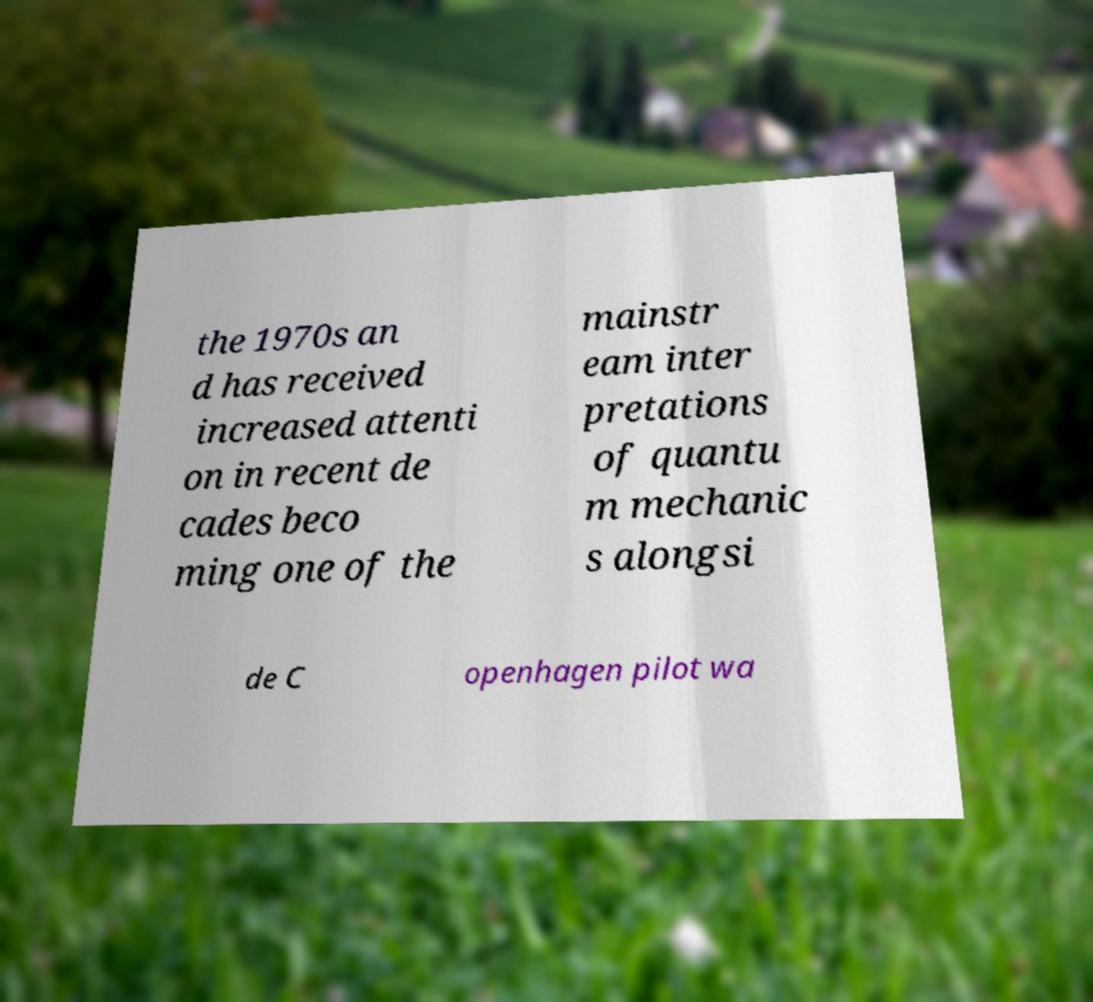For documentation purposes, I need the text within this image transcribed. Could you provide that? the 1970s an d has received increased attenti on in recent de cades beco ming one of the mainstr eam inter pretations of quantu m mechanic s alongsi de C openhagen pilot wa 